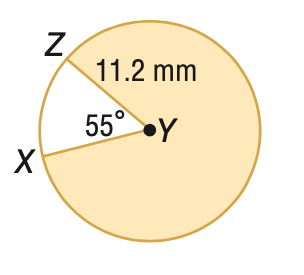Question: Find the area of the shaded sector. Round to the nearest tenth, if necessary.
Choices:
A. 10.8
B. 59.6
C. 60.2
D. 333.9
Answer with the letter. Answer: D 